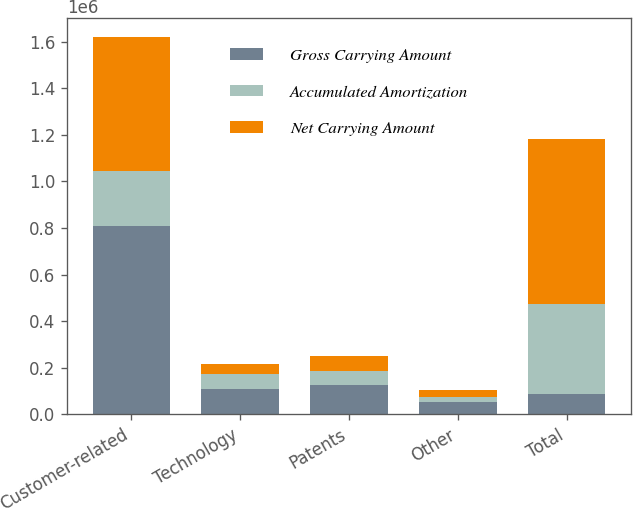Convert chart. <chart><loc_0><loc_0><loc_500><loc_500><stacked_bar_chart><ecel><fcel>Customer-related<fcel>Technology<fcel>Patents<fcel>Other<fcel>Total<nl><fcel>Gross Carrying Amount<fcel>809683<fcel>108929<fcel>124669<fcel>52342<fcel>87191<nl><fcel>Accumulated Amortization<fcel>235315<fcel>65453<fcel>62543<fcel>21930<fcel>385241<nl><fcel>Net Carrying Amount<fcel>574368<fcel>43476<fcel>62126<fcel>30412<fcel>710382<nl></chart> 